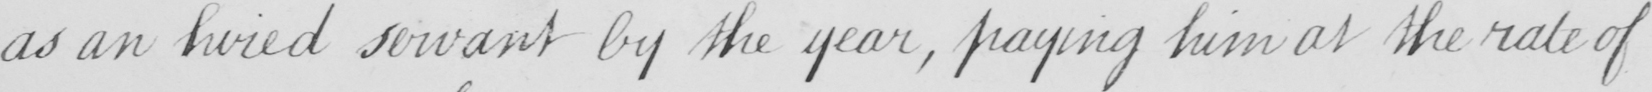What is written in this line of handwriting? as an hired servant by the year , paying him at the rate of 